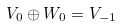<formula> <loc_0><loc_0><loc_500><loc_500>V _ { 0 } \oplus W _ { 0 } = V _ { - 1 }</formula> 